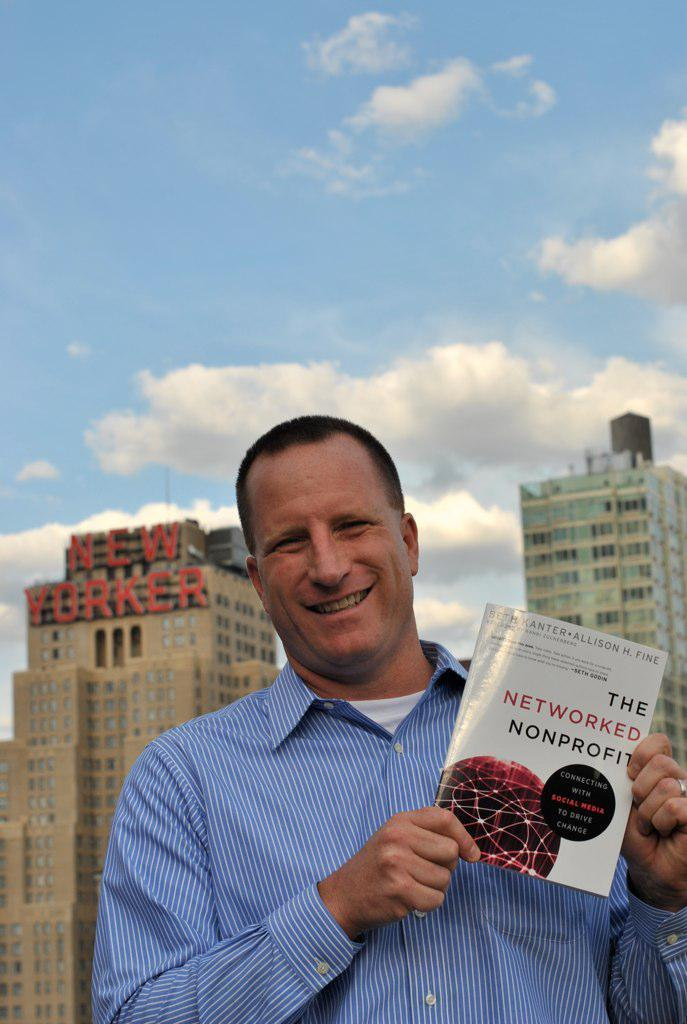<image>
Present a compact description of the photo's key features. A business man in front of the new yorker building holding a book titled the networked nonprofit. 